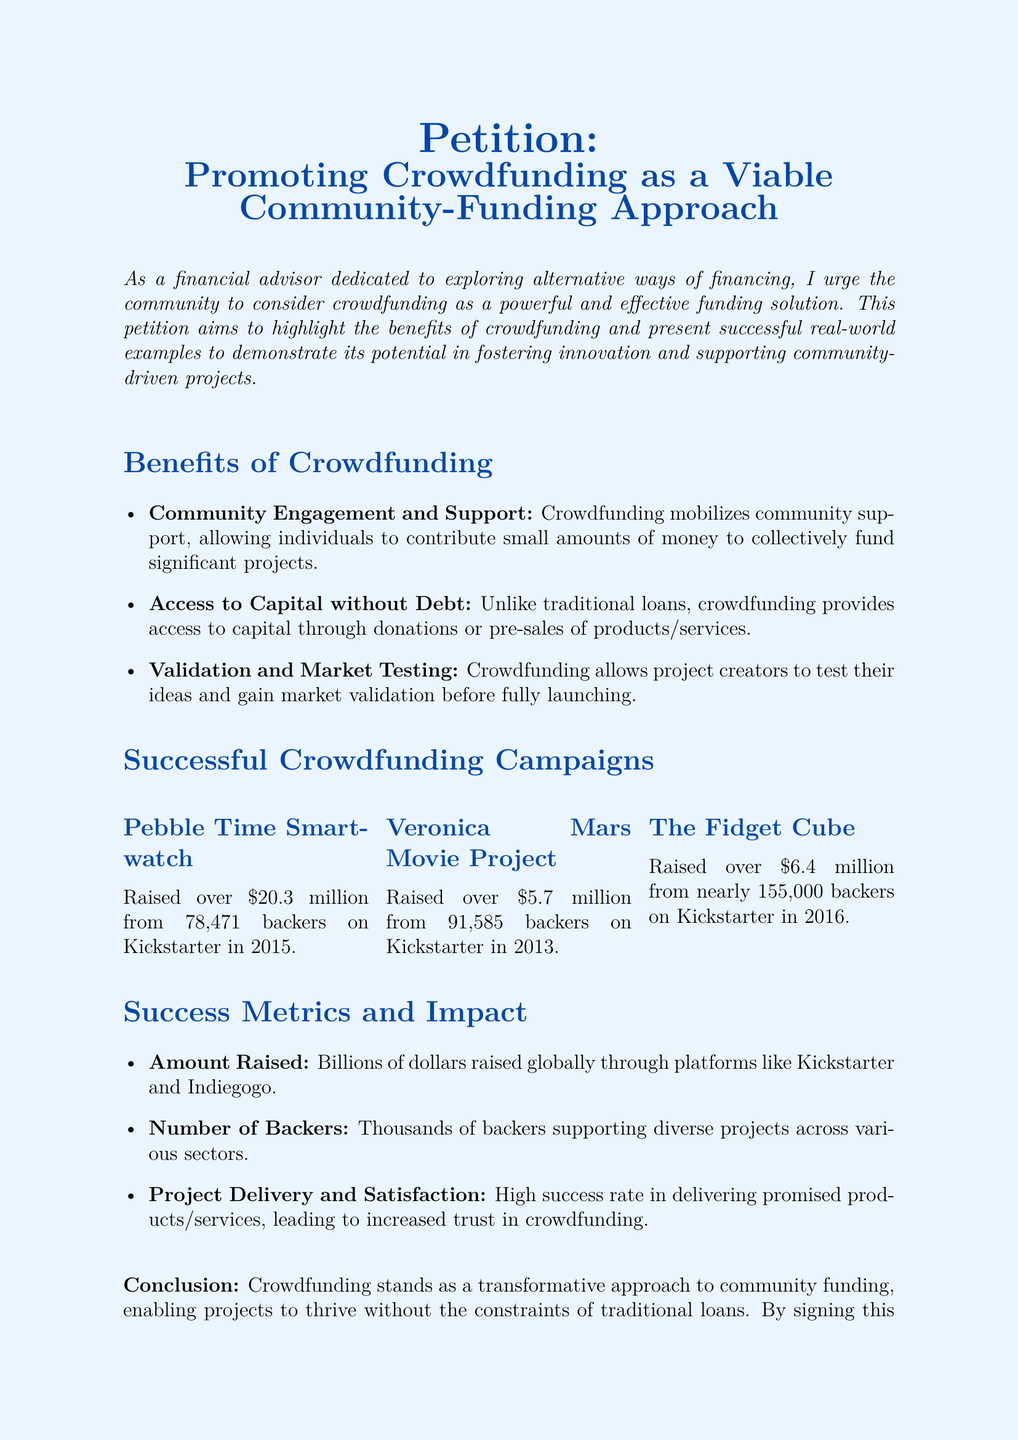What is the title of the petition? The title is explicitly mentioned at the beginning of the document, promoting crowdfunding as a viable community-funding approach.
Answer: Promoting Crowdfunding as a Viable Community-Funding Approach How much did the Pebble Time Smartwatch raise? The amount raised by the Pebble Time Smartwatch is specified in the successful crowdfunding campaigns section.
Answer: over $20.3 million In what year did the Veronica Mars Movie Project launch? The year is included next to the campaign title in the successful crowdfunding campaigns section.
Answer: 2013 What is one benefit of crowdfunding listed in the document? The document lists multiple benefits, with the first one being community engagement and support.
Answer: Community Engagement and Support How many backers supported The Fidget Cube campaign? The number of backers for The Fidget Cube is indicated in the successful crowdfunding campaigns section.
Answer: nearly 155,000 What does crowdfunding provide access to, according to the document? This is addressed in the benefits section, which contrasts crowdfunding with traditional loans.
Answer: Capital without Debt What was a key success metric in crowdfunding? The document outlines success metrics that include the amount raised, number of backers, and project delivery.
Answer: Amount Raised What is the overall conclusion regarding crowdfunding? The concluding section summarizes the position that crowdfunding is a transformative approach to funding.
Answer: A transformative approach to community funding What type of projects does the petition aim to support? The document specifies that the petition supports innovators, entrepreneurs, and community-driven initiatives.
Answer: Innovators, Entrepreneurs, and Community-driven Initiatives 